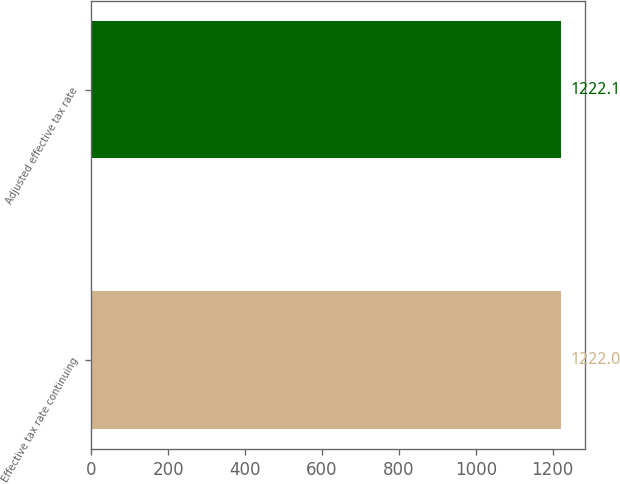Convert chart to OTSL. <chart><loc_0><loc_0><loc_500><loc_500><bar_chart><fcel>Effective tax rate continuing<fcel>Adjusted effective tax rate<nl><fcel>1222<fcel>1222.1<nl></chart> 